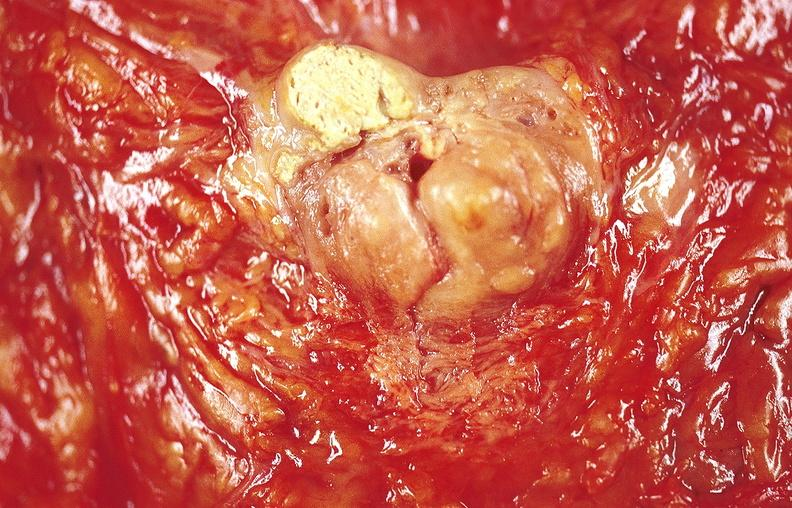what does this image show?
Answer the question using a single word or phrase. Gastric ulcer 